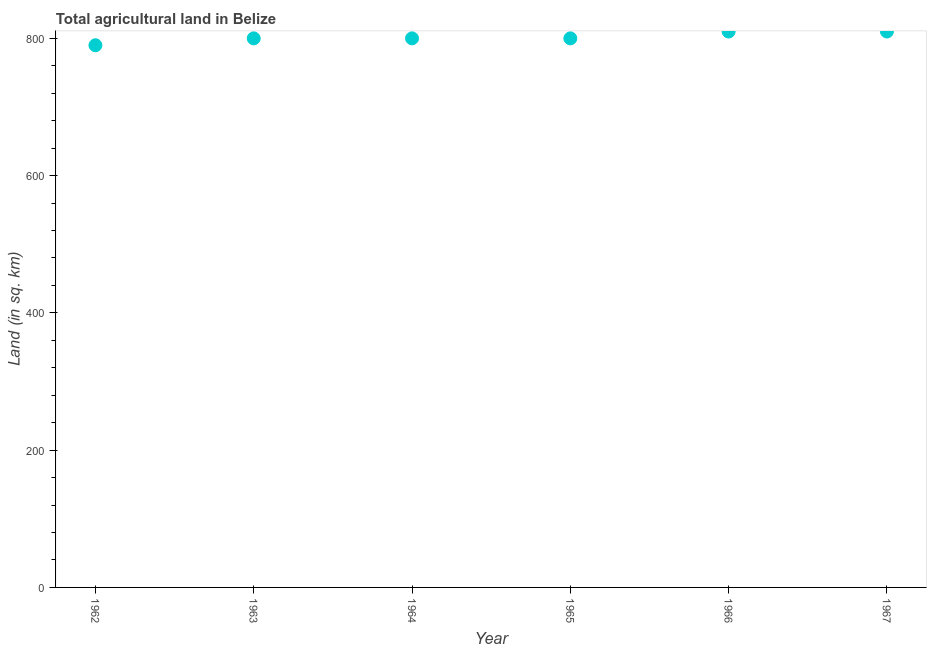What is the agricultural land in 1963?
Make the answer very short. 800. Across all years, what is the maximum agricultural land?
Your response must be concise. 810. Across all years, what is the minimum agricultural land?
Offer a terse response. 790. In which year was the agricultural land maximum?
Give a very brief answer. 1966. In which year was the agricultural land minimum?
Keep it short and to the point. 1962. What is the sum of the agricultural land?
Make the answer very short. 4810. What is the difference between the agricultural land in 1965 and 1967?
Ensure brevity in your answer.  -10. What is the average agricultural land per year?
Your answer should be compact. 801.67. What is the median agricultural land?
Your answer should be compact. 800. Do a majority of the years between 1967 and 1965 (inclusive) have agricultural land greater than 560 sq. km?
Your response must be concise. No. What is the ratio of the agricultural land in 1963 to that in 1964?
Give a very brief answer. 1. Is the agricultural land in 1965 less than that in 1967?
Your response must be concise. Yes. Is the difference between the agricultural land in 1962 and 1965 greater than the difference between any two years?
Your response must be concise. No. What is the difference between the highest and the lowest agricultural land?
Your response must be concise. 20. In how many years, is the agricultural land greater than the average agricultural land taken over all years?
Offer a very short reply. 2. How many years are there in the graph?
Offer a very short reply. 6. Does the graph contain any zero values?
Offer a very short reply. No. Does the graph contain grids?
Offer a terse response. No. What is the title of the graph?
Keep it short and to the point. Total agricultural land in Belize. What is the label or title of the Y-axis?
Provide a succinct answer. Land (in sq. km). What is the Land (in sq. km) in 1962?
Provide a succinct answer. 790. What is the Land (in sq. km) in 1963?
Offer a very short reply. 800. What is the Land (in sq. km) in 1964?
Offer a very short reply. 800. What is the Land (in sq. km) in 1965?
Make the answer very short. 800. What is the Land (in sq. km) in 1966?
Provide a succinct answer. 810. What is the Land (in sq. km) in 1967?
Give a very brief answer. 810. What is the difference between the Land (in sq. km) in 1962 and 1964?
Offer a terse response. -10. What is the difference between the Land (in sq. km) in 1962 and 1965?
Make the answer very short. -10. What is the difference between the Land (in sq. km) in 1962 and 1967?
Provide a short and direct response. -20. What is the difference between the Land (in sq. km) in 1963 and 1967?
Offer a terse response. -10. What is the difference between the Land (in sq. km) in 1964 and 1966?
Provide a short and direct response. -10. What is the difference between the Land (in sq. km) in 1964 and 1967?
Provide a short and direct response. -10. What is the difference between the Land (in sq. km) in 1966 and 1967?
Offer a very short reply. 0. What is the ratio of the Land (in sq. km) in 1962 to that in 1965?
Your response must be concise. 0.99. What is the ratio of the Land (in sq. km) in 1962 to that in 1966?
Your answer should be compact. 0.97. What is the ratio of the Land (in sq. km) in 1962 to that in 1967?
Your response must be concise. 0.97. What is the ratio of the Land (in sq. km) in 1963 to that in 1964?
Keep it short and to the point. 1. What is the ratio of the Land (in sq. km) in 1963 to that in 1967?
Your answer should be very brief. 0.99. What is the ratio of the Land (in sq. km) in 1964 to that in 1965?
Offer a very short reply. 1. What is the ratio of the Land (in sq. km) in 1964 to that in 1967?
Keep it short and to the point. 0.99. What is the ratio of the Land (in sq. km) in 1965 to that in 1967?
Offer a very short reply. 0.99. 